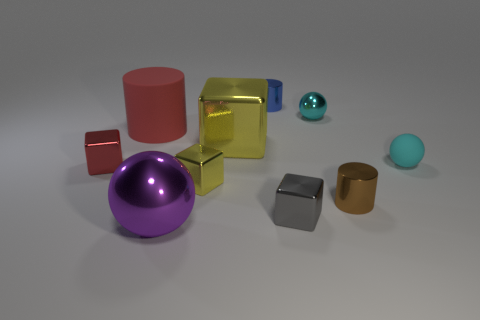Subtract all cyan balls. How many were subtracted if there are1cyan balls left? 1 Subtract 1 cubes. How many cubes are left? 3 Subtract all cylinders. How many objects are left? 7 Add 4 metal spheres. How many metal spheres are left? 6 Add 1 small blue things. How many small blue things exist? 2 Subtract 1 red cubes. How many objects are left? 9 Subtract all cyan blocks. Subtract all red cubes. How many objects are left? 9 